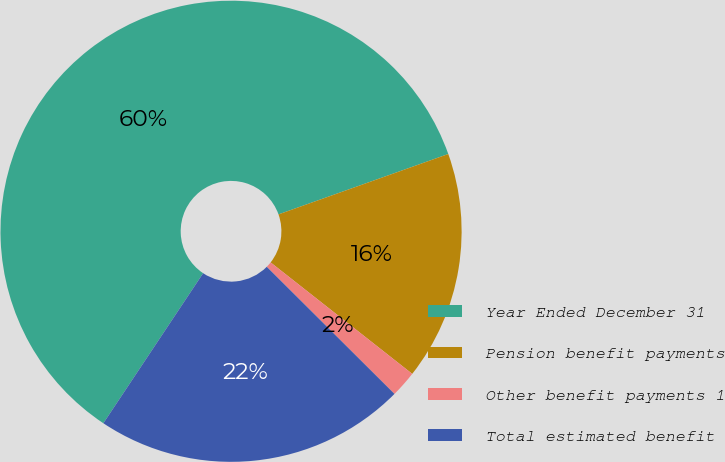Convert chart to OTSL. <chart><loc_0><loc_0><loc_500><loc_500><pie_chart><fcel>Year Ended December 31<fcel>Pension benefit payments<fcel>Other benefit payments 1<fcel>Total estimated benefit<nl><fcel>60.22%<fcel>16.05%<fcel>1.85%<fcel>21.88%<nl></chart> 